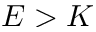<formula> <loc_0><loc_0><loc_500><loc_500>E > K</formula> 